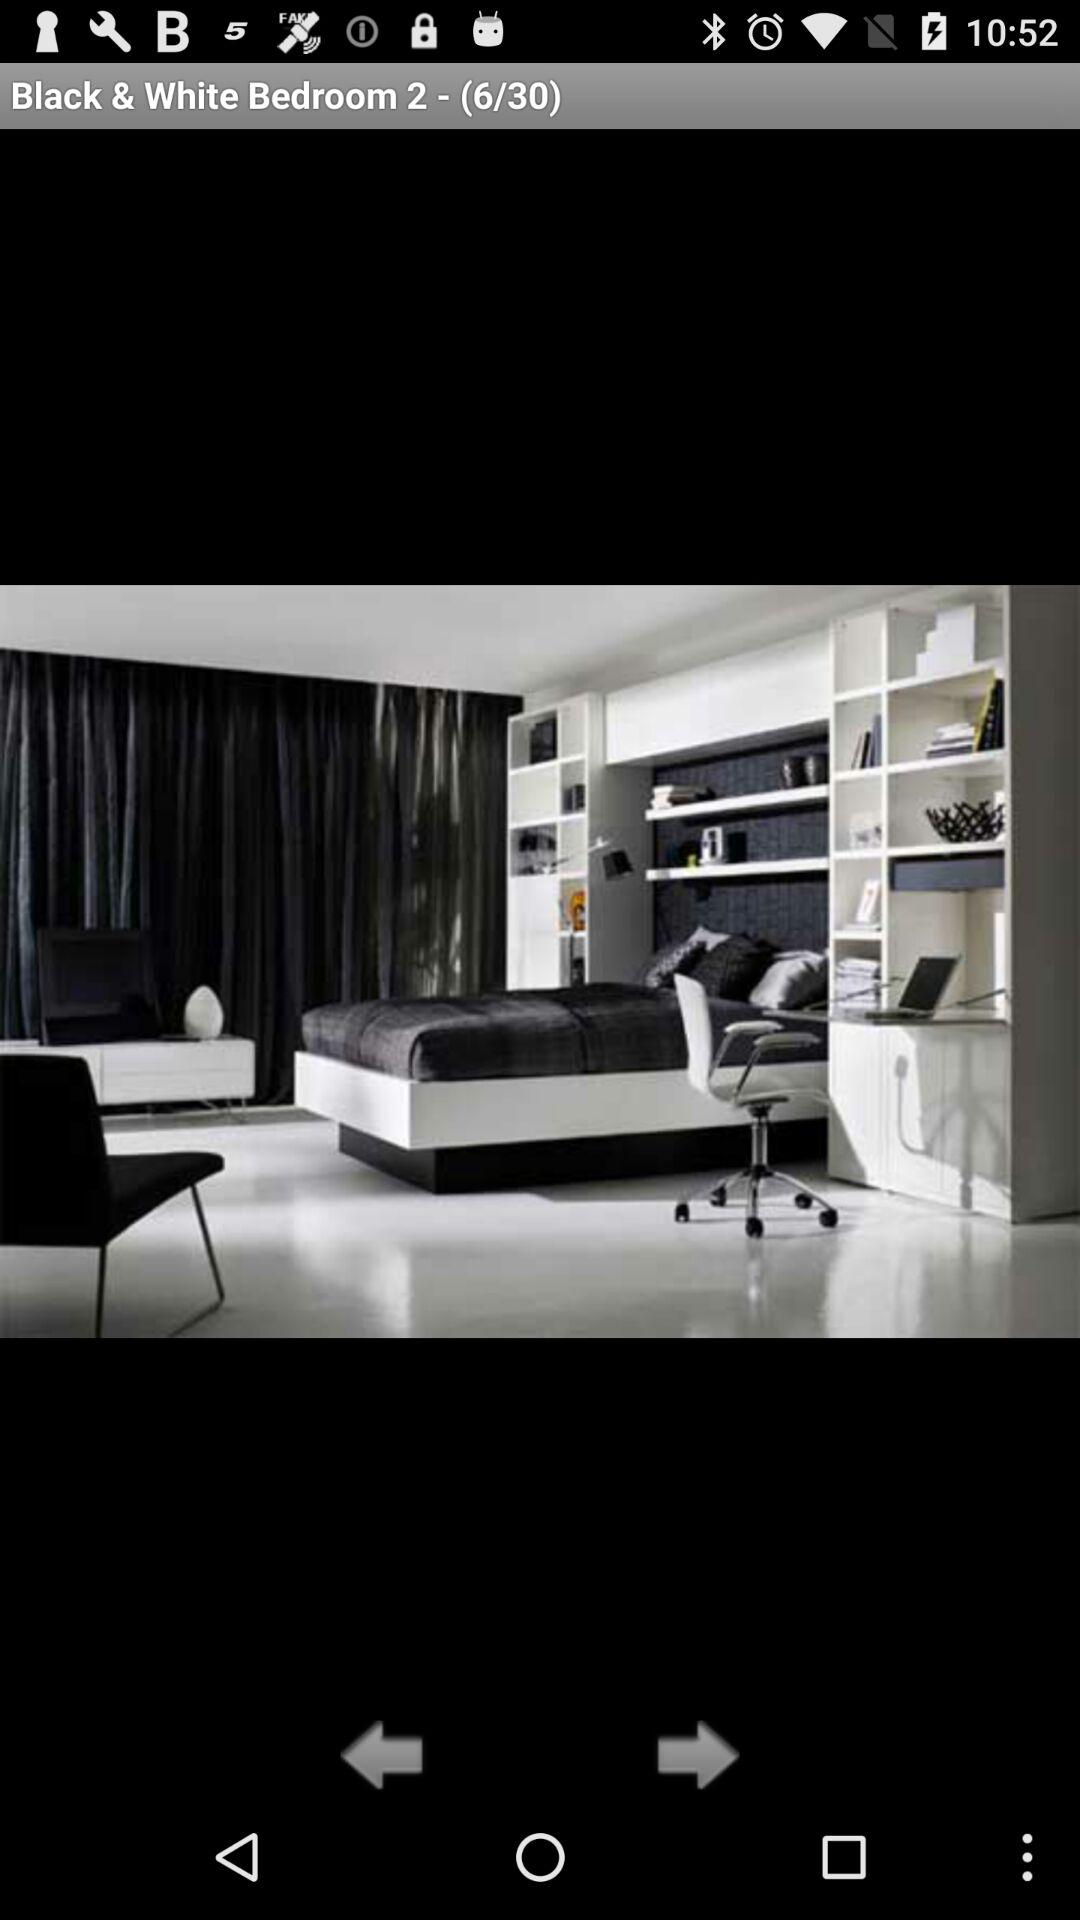What image of a bedroom am I? You are on the 6th image. 